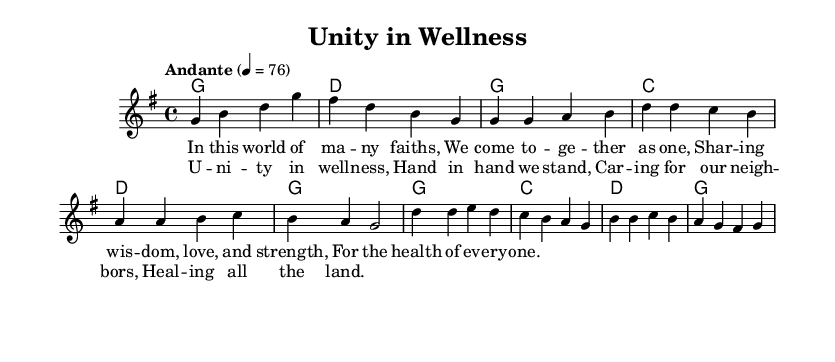What is the key signature of this music? The key signature is indicated at the beginning of the music, where there is one sharp, which corresponds to G major.
Answer: G major What is the time signature of this music? The time signature is found near the beginning of the music, represented by the fraction in the form of 4 over 4, indicating four beats per measure.
Answer: 4/4 What is the tempo marking for this piece? The tempo marking is also given near the beginning and it states "Andante" with a metronome marking of 76 beats per minute, indicating a moderate pace.
Answer: Andante How many measures are in the chorus? To find this, we count the measures indicated in the chorus section of the music, which consists of four measures in total.
Answer: 4 What is the main theme of the lyrics? The main theme can be discerned by reading the lyrics, which emphasize unity, community health, and caring for one another, reflecting an interfaith message.
Answer: Unity in wellness Which section contains the lyrics beginning with "In this world of many faiths"? By looking at the layout of the lyrics in the score, this line belongs to the verse section, as indicated before the lyrics in that portion.
Answer: Verse 